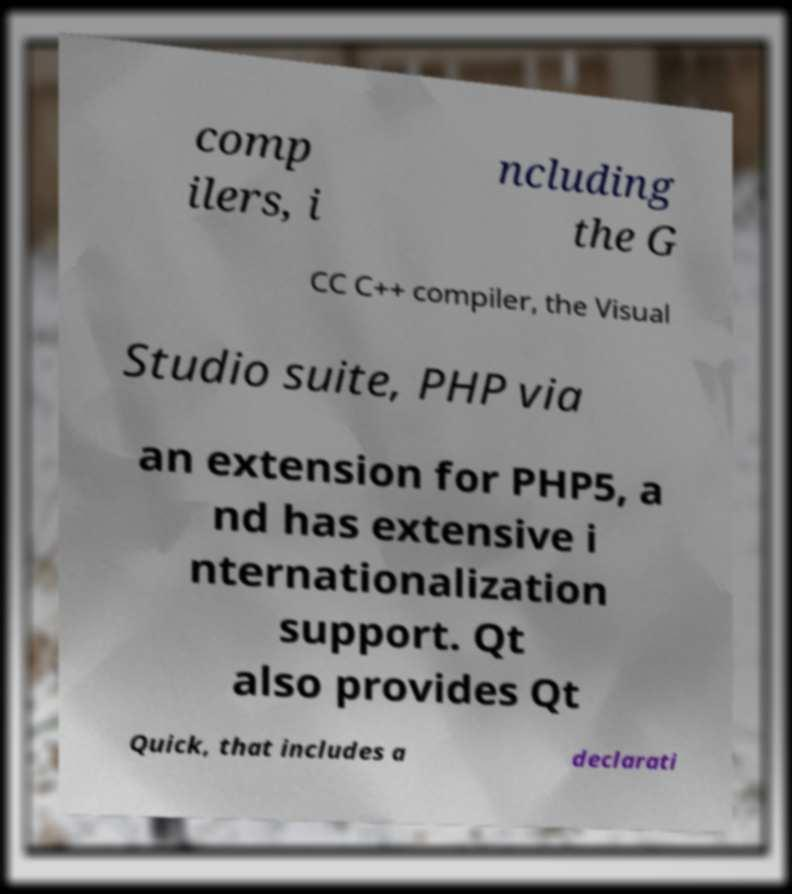Can you accurately transcribe the text from the provided image for me? comp ilers, i ncluding the G CC C++ compiler, the Visual Studio suite, PHP via an extension for PHP5, a nd has extensive i nternationalization support. Qt also provides Qt Quick, that includes a declarati 